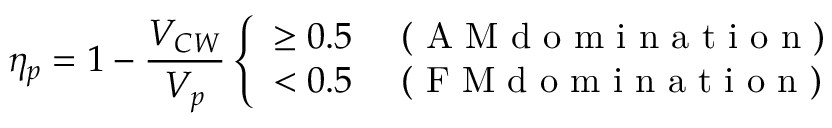Convert formula to latex. <formula><loc_0><loc_0><loc_500><loc_500>\eta _ { p } = 1 - \frac { V _ { C W } } { V _ { p } } \left \{ \begin{array} { l l } { \geq 0 . 5 } & { ( A M d o m i n a t i o n ) } \\ { < 0 . 5 } & { ( F M d o m i n a t i o n ) } \end{array}</formula> 